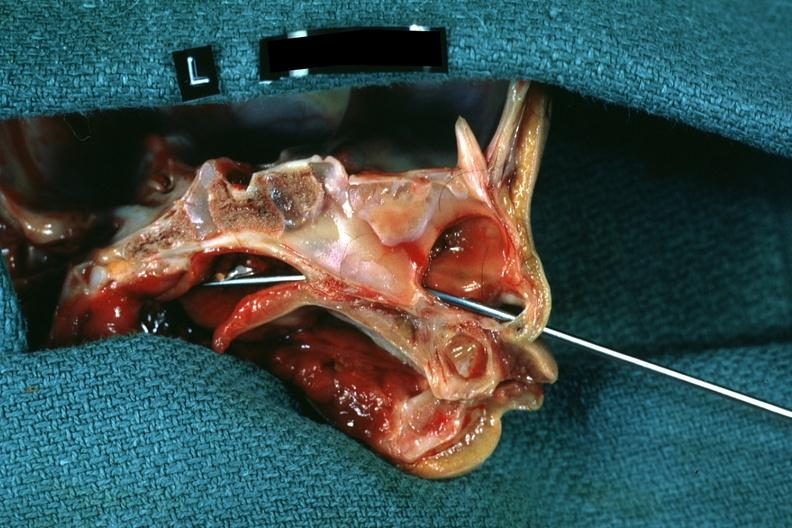s choanal patency present?
Answer the question using a single word or phrase. Yes 